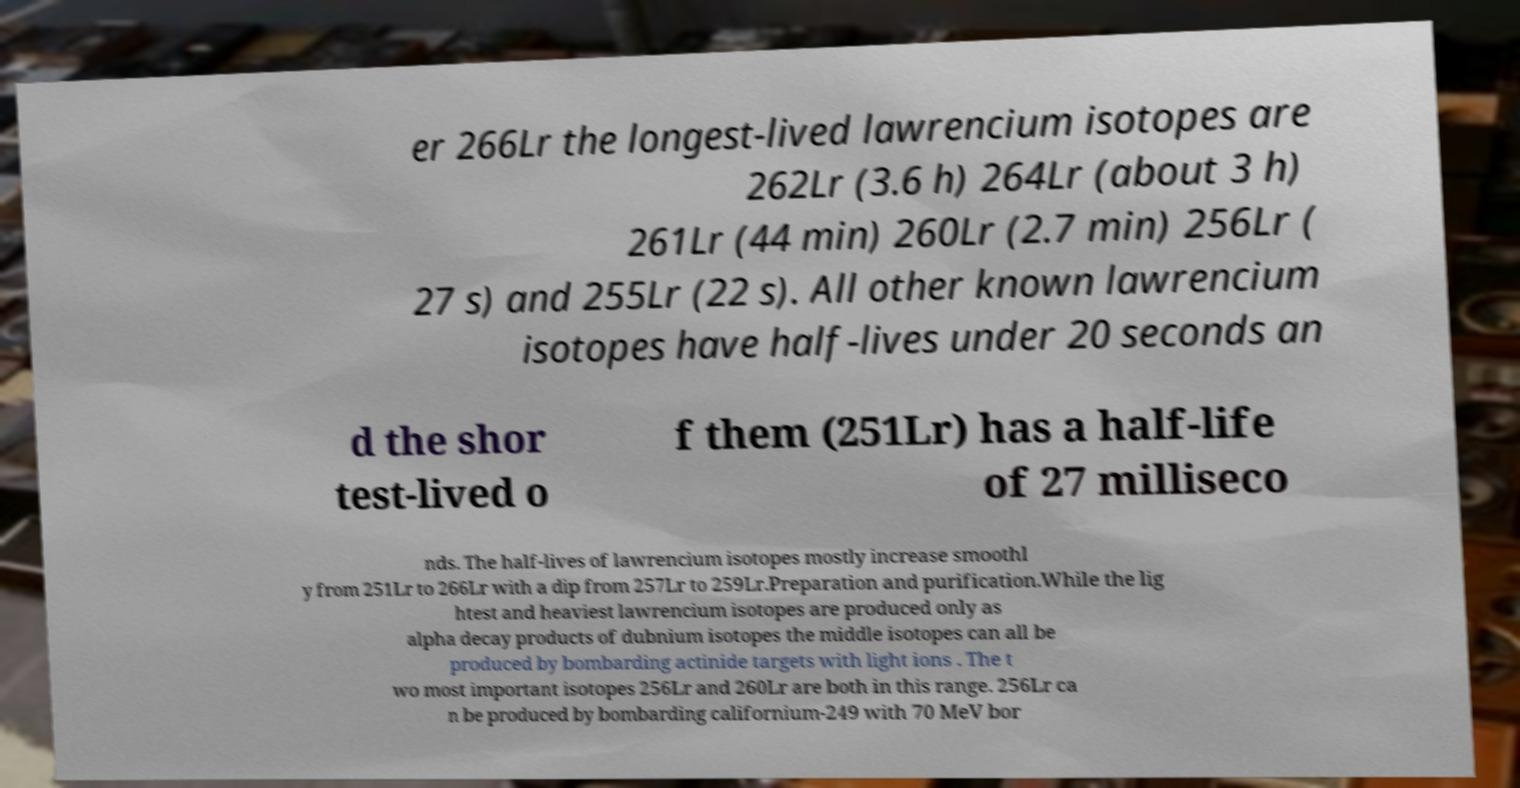Could you assist in decoding the text presented in this image and type it out clearly? er 266Lr the longest-lived lawrencium isotopes are 262Lr (3.6 h) 264Lr (about 3 h) 261Lr (44 min) 260Lr (2.7 min) 256Lr ( 27 s) and 255Lr (22 s). All other known lawrencium isotopes have half-lives under 20 seconds an d the shor test-lived o f them (251Lr) has a half-life of 27 milliseco nds. The half-lives of lawrencium isotopes mostly increase smoothl y from 251Lr to 266Lr with a dip from 257Lr to 259Lr.Preparation and purification.While the lig htest and heaviest lawrencium isotopes are produced only as alpha decay products of dubnium isotopes the middle isotopes can all be produced by bombarding actinide targets with light ions . The t wo most important isotopes 256Lr and 260Lr are both in this range. 256Lr ca n be produced by bombarding californium-249 with 70 MeV bor 